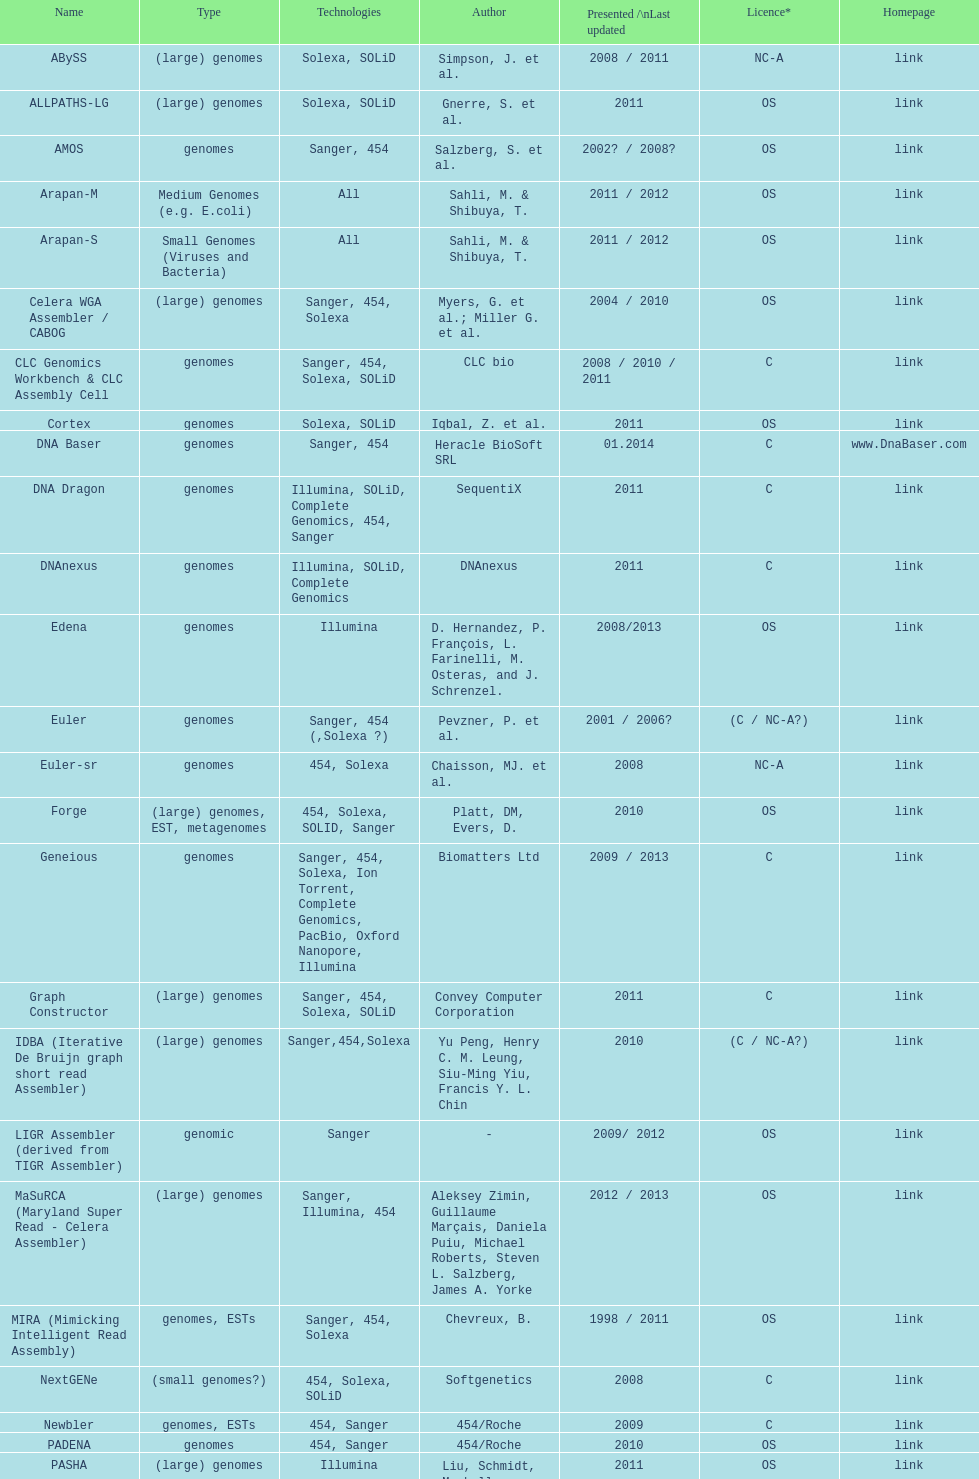What is the latest presentation or revised? DNA Baser. 